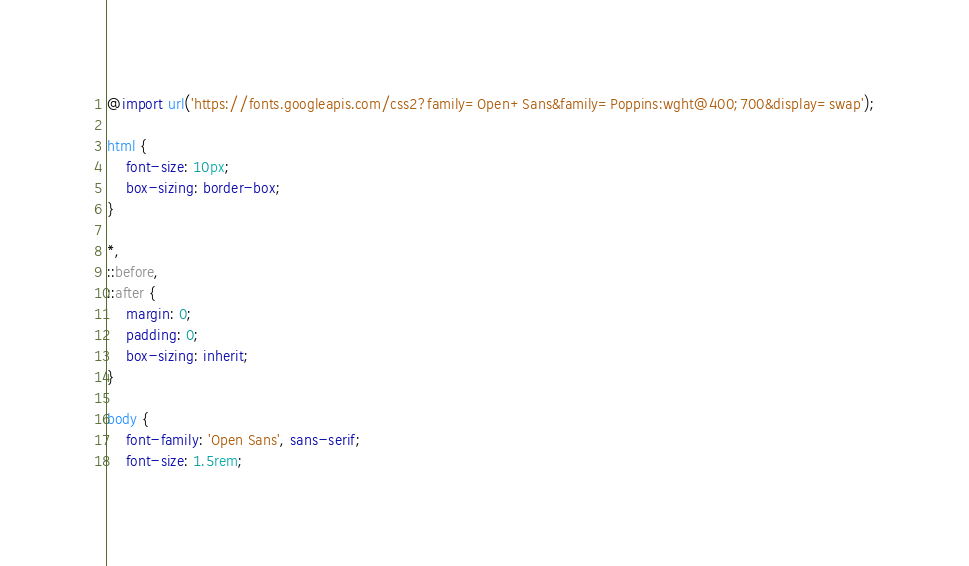<code> <loc_0><loc_0><loc_500><loc_500><_CSS_>@import url('https://fonts.googleapis.com/css2?family=Open+Sans&family=Poppins:wght@400;700&display=swap');

html {
	font-size: 10px;
	box-sizing: border-box;
}

*,
::before,
::after {
	margin: 0;
	padding: 0;
	box-sizing: inherit;
}

body {
	font-family: 'Open Sans', sans-serif;
	font-size: 1.5rem;</code> 